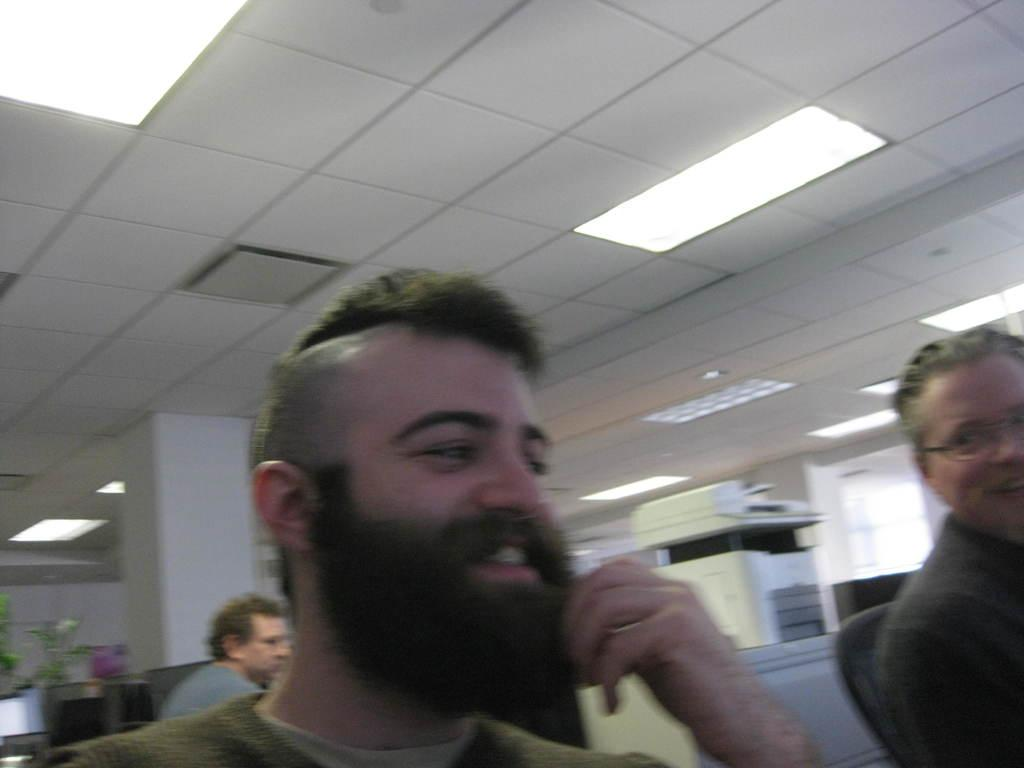How many men are visible in the image? There are two men visible in the image. Where is the first man located in the image? The first man is in the center of the image. Where is the second man located in the image? The second man is on the right side of the image. What can be seen at the top side of the image? There are lights visible at the top side of the image. Is there a river flowing through the image? There is no river present in the image. What level of the building are the men standing on in the image? The image does not provide information about the level or floor of the building, so it cannot be determined from the image. 